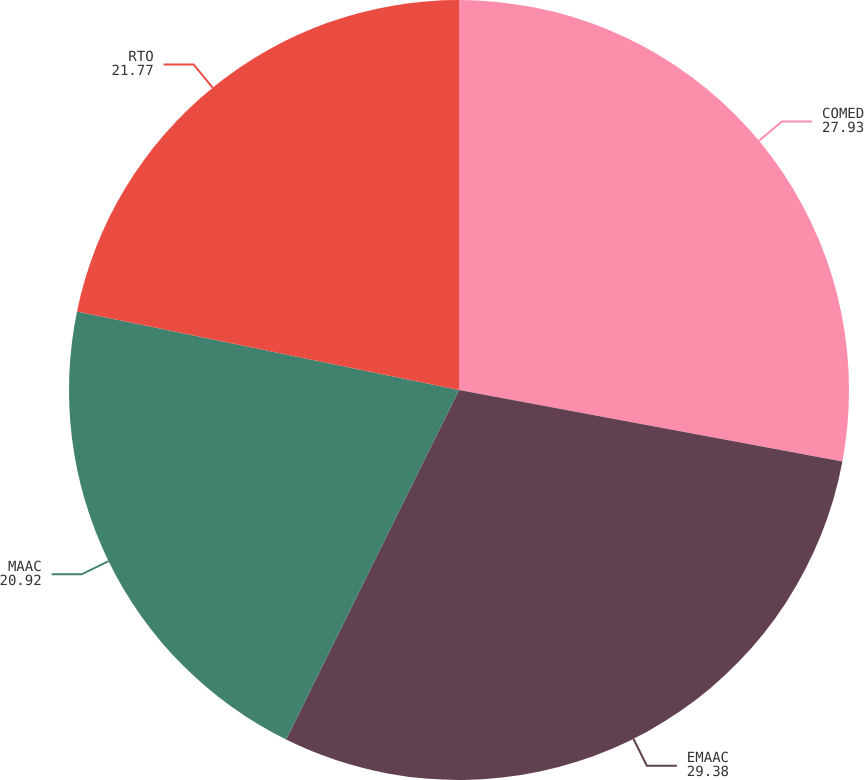Convert chart to OTSL. <chart><loc_0><loc_0><loc_500><loc_500><pie_chart><fcel>COMED<fcel>EMAAC<fcel>MAAC<fcel>RTO<nl><fcel>27.93%<fcel>29.38%<fcel>20.92%<fcel>21.77%<nl></chart> 